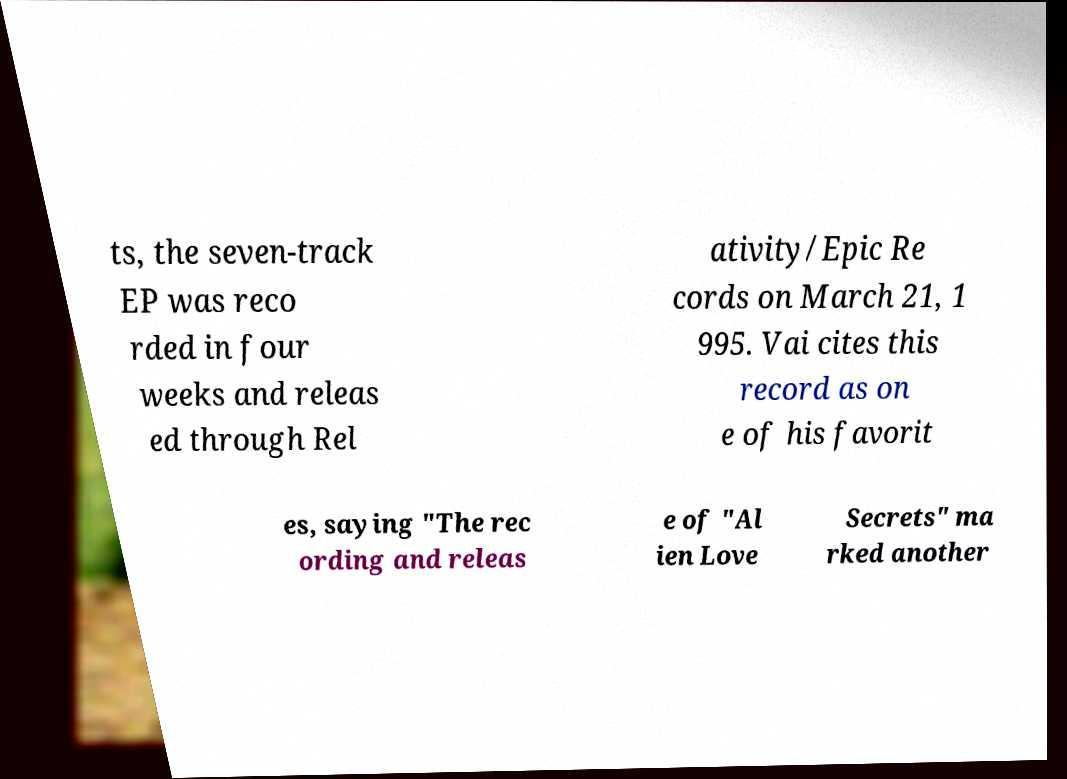Please read and relay the text visible in this image. What does it say? ts, the seven-track EP was reco rded in four weeks and releas ed through Rel ativity/Epic Re cords on March 21, 1 995. Vai cites this record as on e of his favorit es, saying "The rec ording and releas e of "Al ien Love Secrets" ma rked another 